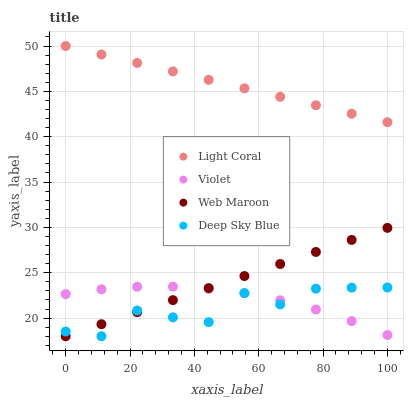Does Deep Sky Blue have the minimum area under the curve?
Answer yes or no. Yes. Does Light Coral have the maximum area under the curve?
Answer yes or no. Yes. Does Web Maroon have the minimum area under the curve?
Answer yes or no. No. Does Web Maroon have the maximum area under the curve?
Answer yes or no. No. Is Web Maroon the smoothest?
Answer yes or no. Yes. Is Deep Sky Blue the roughest?
Answer yes or no. Yes. Is Deep Sky Blue the smoothest?
Answer yes or no. No. Is Web Maroon the roughest?
Answer yes or no. No. Does Web Maroon have the lowest value?
Answer yes or no. Yes. Does Violet have the lowest value?
Answer yes or no. No. Does Light Coral have the highest value?
Answer yes or no. Yes. Does Web Maroon have the highest value?
Answer yes or no. No. Is Violet less than Light Coral?
Answer yes or no. Yes. Is Light Coral greater than Deep Sky Blue?
Answer yes or no. Yes. Does Deep Sky Blue intersect Violet?
Answer yes or no. Yes. Is Deep Sky Blue less than Violet?
Answer yes or no. No. Is Deep Sky Blue greater than Violet?
Answer yes or no. No. Does Violet intersect Light Coral?
Answer yes or no. No. 